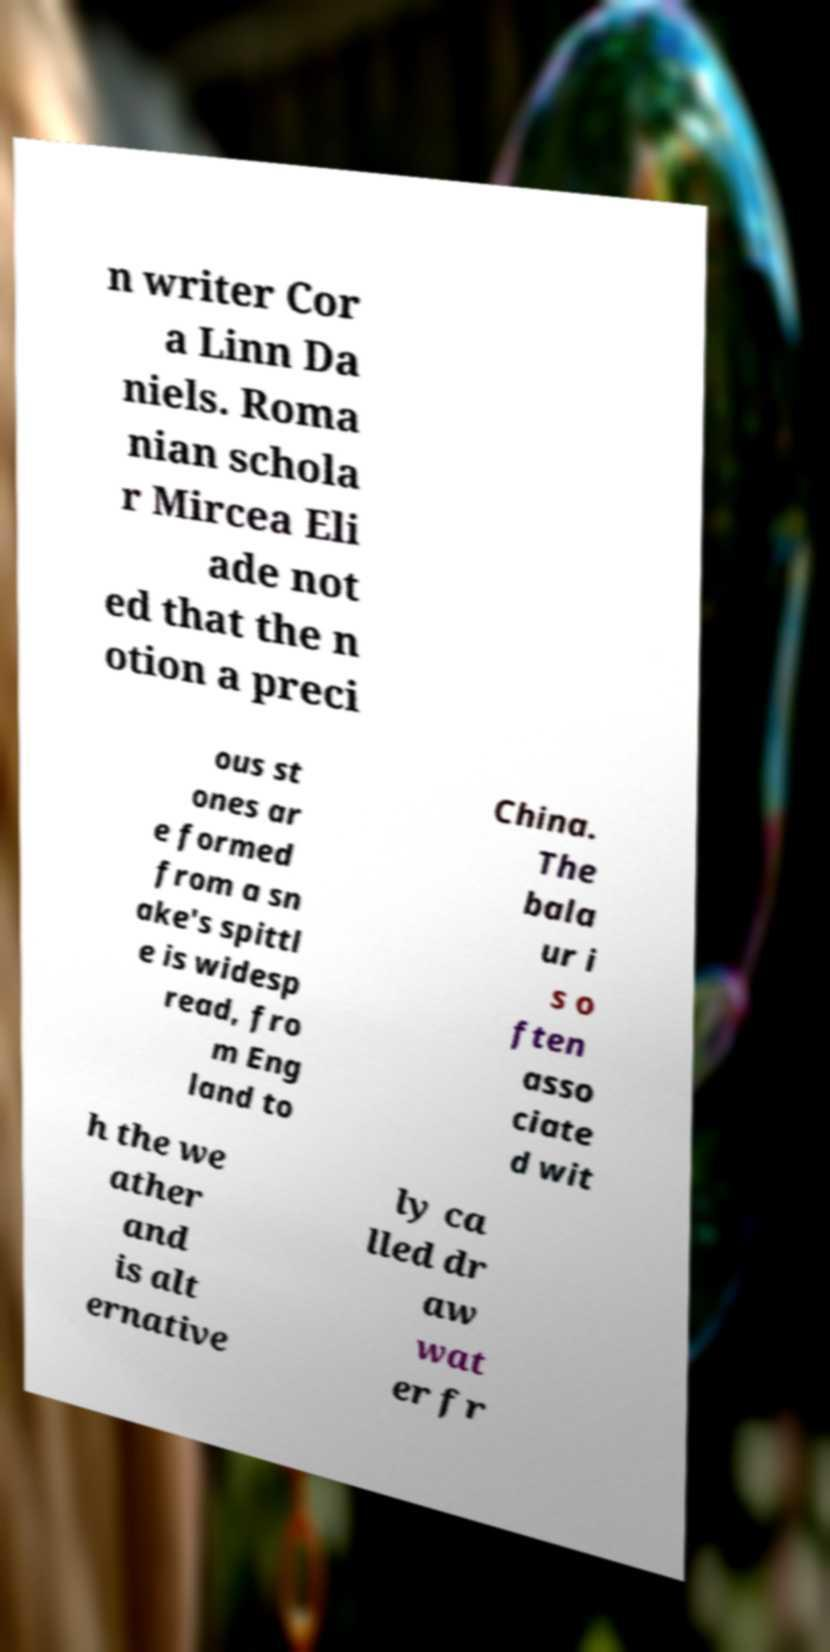I need the written content from this picture converted into text. Can you do that? n writer Cor a Linn Da niels. Roma nian schola r Mircea Eli ade not ed that the n otion a preci ous st ones ar e formed from a sn ake's spittl e is widesp read, fro m Eng land to China. The bala ur i s o ften asso ciate d wit h the we ather and is alt ernative ly ca lled dr aw wat er fr 